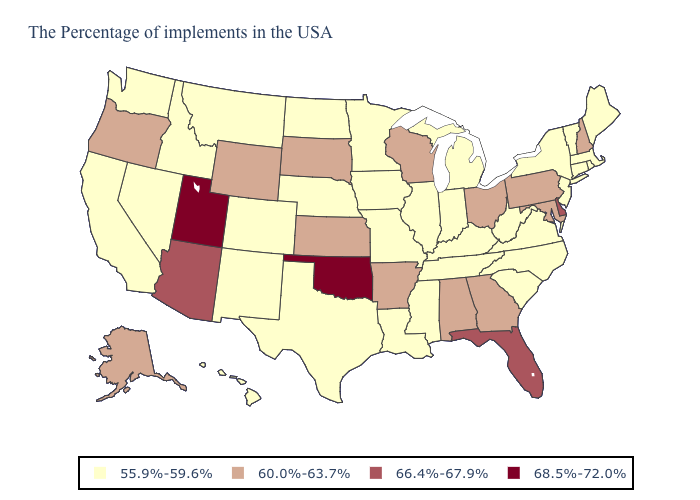Among the states that border New Jersey , does Pennsylvania have the lowest value?
Give a very brief answer. No. What is the value of South Carolina?
Keep it brief. 55.9%-59.6%. Which states hav the highest value in the Northeast?
Write a very short answer. New Hampshire, Pennsylvania. Among the states that border Georgia , does Florida have the lowest value?
Short answer required. No. What is the lowest value in the West?
Concise answer only. 55.9%-59.6%. Which states have the highest value in the USA?
Quick response, please. Oklahoma, Utah. What is the value of Arkansas?
Answer briefly. 60.0%-63.7%. Name the states that have a value in the range 60.0%-63.7%?
Keep it brief. New Hampshire, Maryland, Pennsylvania, Ohio, Georgia, Alabama, Wisconsin, Arkansas, Kansas, South Dakota, Wyoming, Oregon, Alaska. Name the states that have a value in the range 68.5%-72.0%?
Quick response, please. Oklahoma, Utah. How many symbols are there in the legend?
Be succinct. 4. What is the value of Oregon?
Answer briefly. 60.0%-63.7%. Name the states that have a value in the range 55.9%-59.6%?
Be succinct. Maine, Massachusetts, Rhode Island, Vermont, Connecticut, New York, New Jersey, Virginia, North Carolina, South Carolina, West Virginia, Michigan, Kentucky, Indiana, Tennessee, Illinois, Mississippi, Louisiana, Missouri, Minnesota, Iowa, Nebraska, Texas, North Dakota, Colorado, New Mexico, Montana, Idaho, Nevada, California, Washington, Hawaii. Is the legend a continuous bar?
Answer briefly. No. Name the states that have a value in the range 68.5%-72.0%?
Keep it brief. Oklahoma, Utah. Among the states that border Nevada , which have the lowest value?
Concise answer only. Idaho, California. 